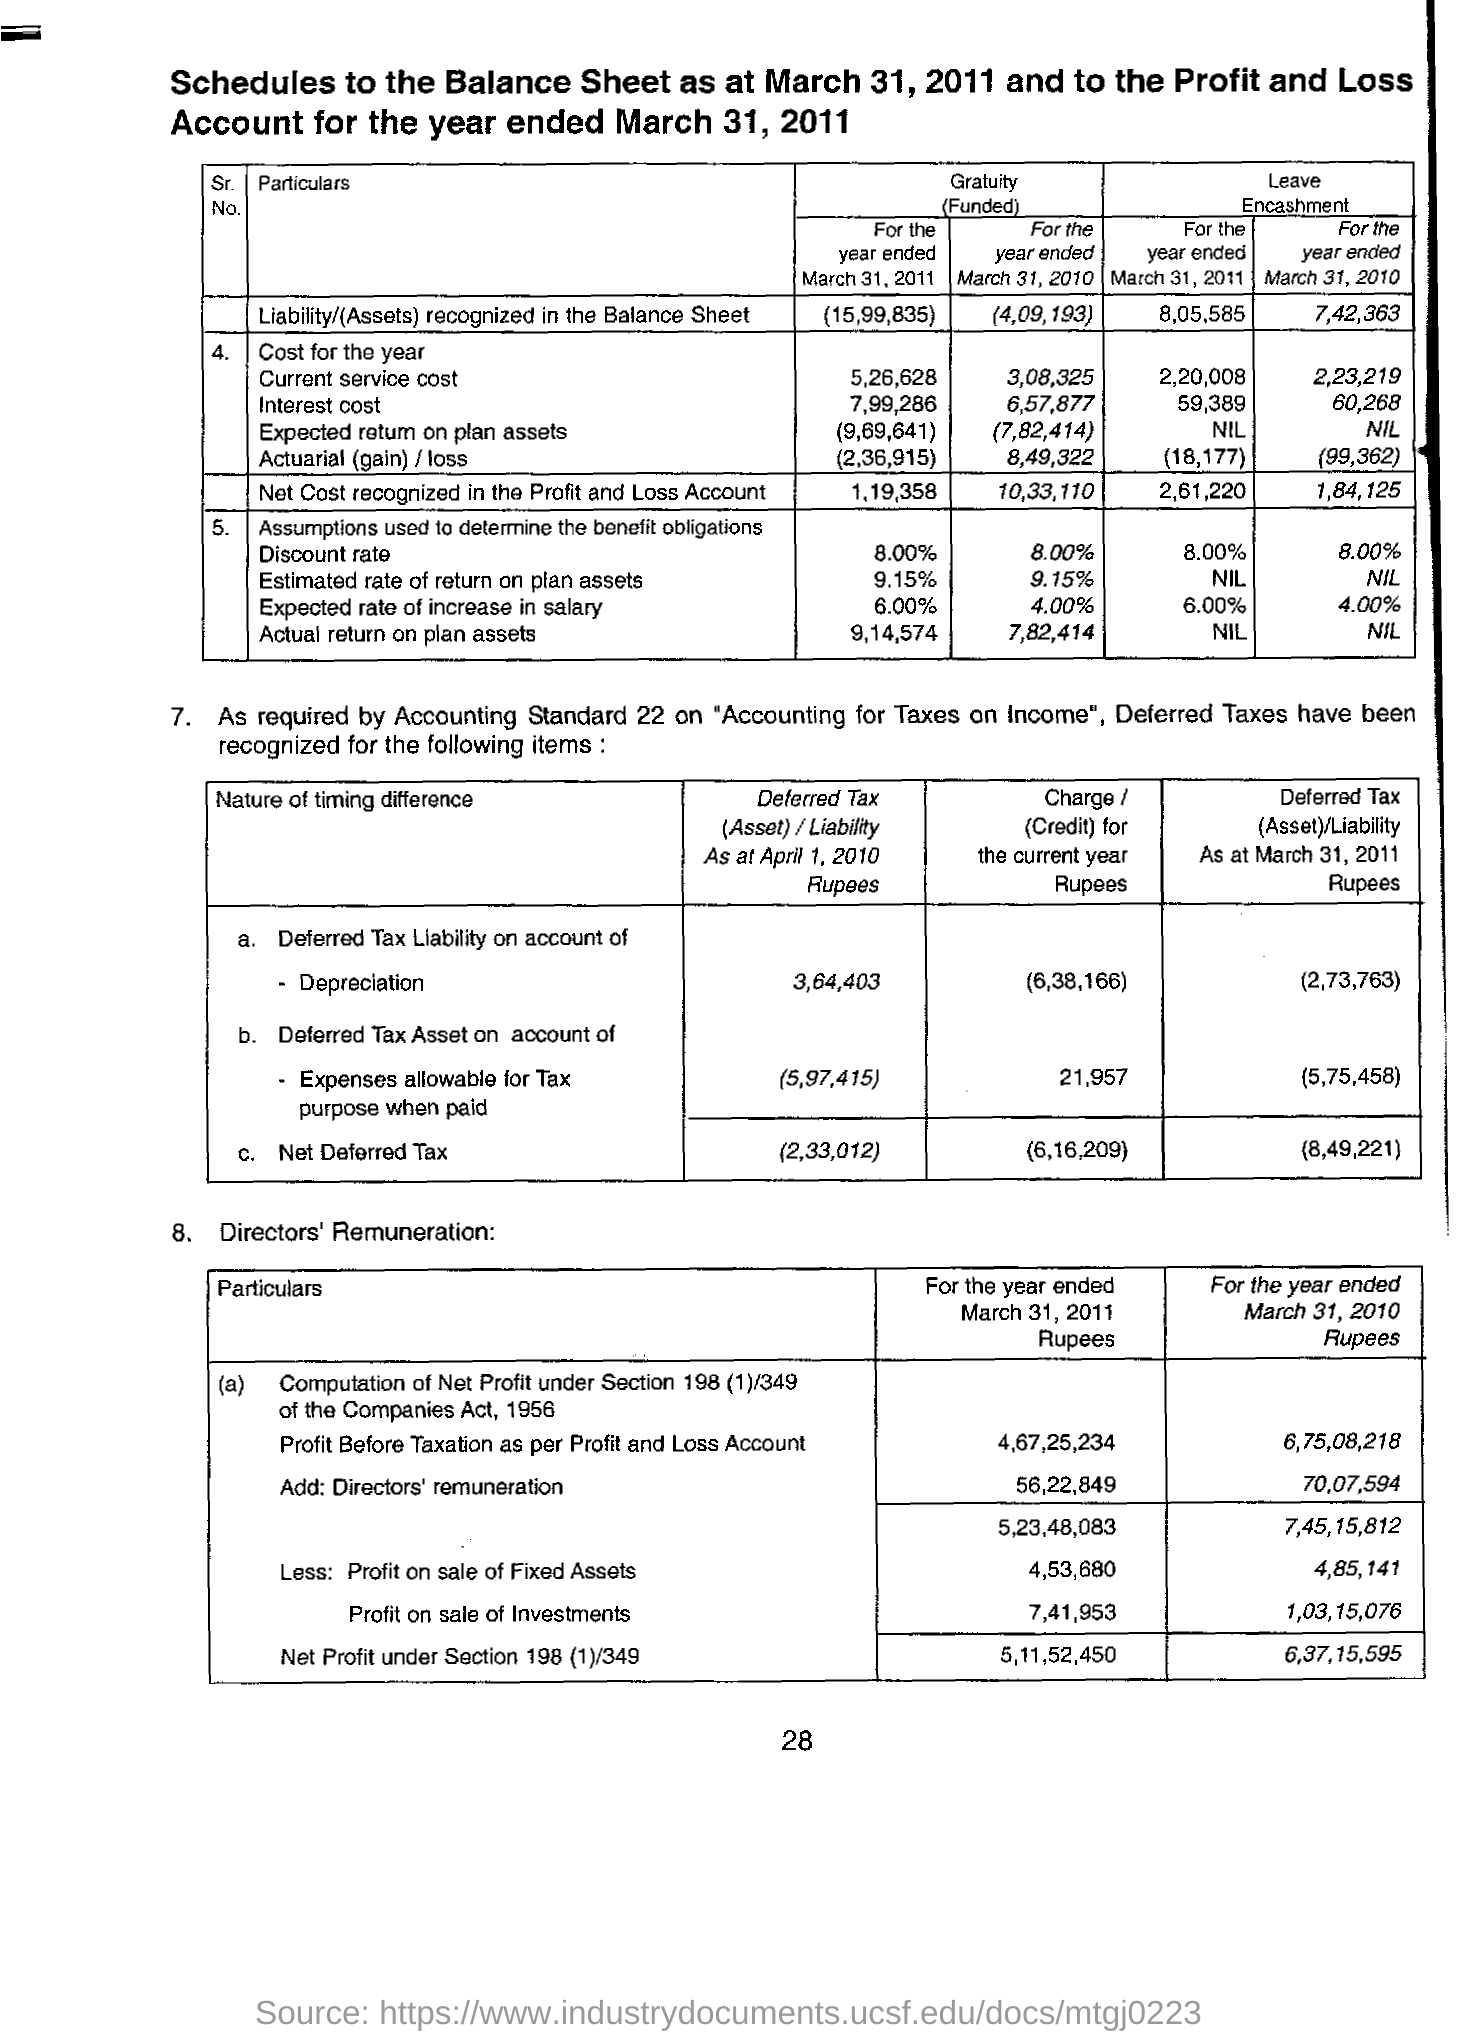Give some essential details in this illustration. The net deferred tax liability on account of depreciation as of April 2010 was 364,403. As stated on the specified page, March 31, 2011, is the scheduled date and year. As of April 2010, the net deferred amount was 233012... 